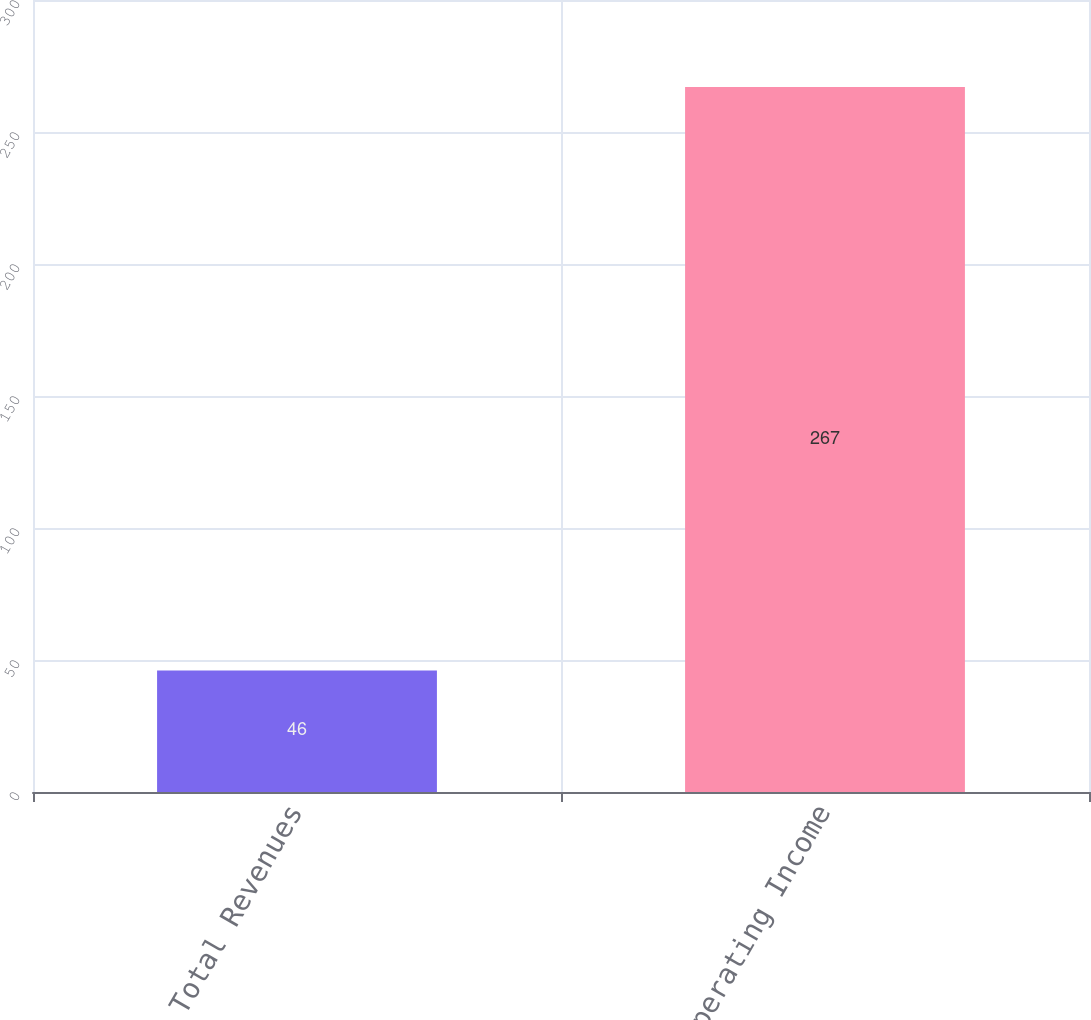<chart> <loc_0><loc_0><loc_500><loc_500><bar_chart><fcel>Total Revenues<fcel>Operating Income<nl><fcel>46<fcel>267<nl></chart> 